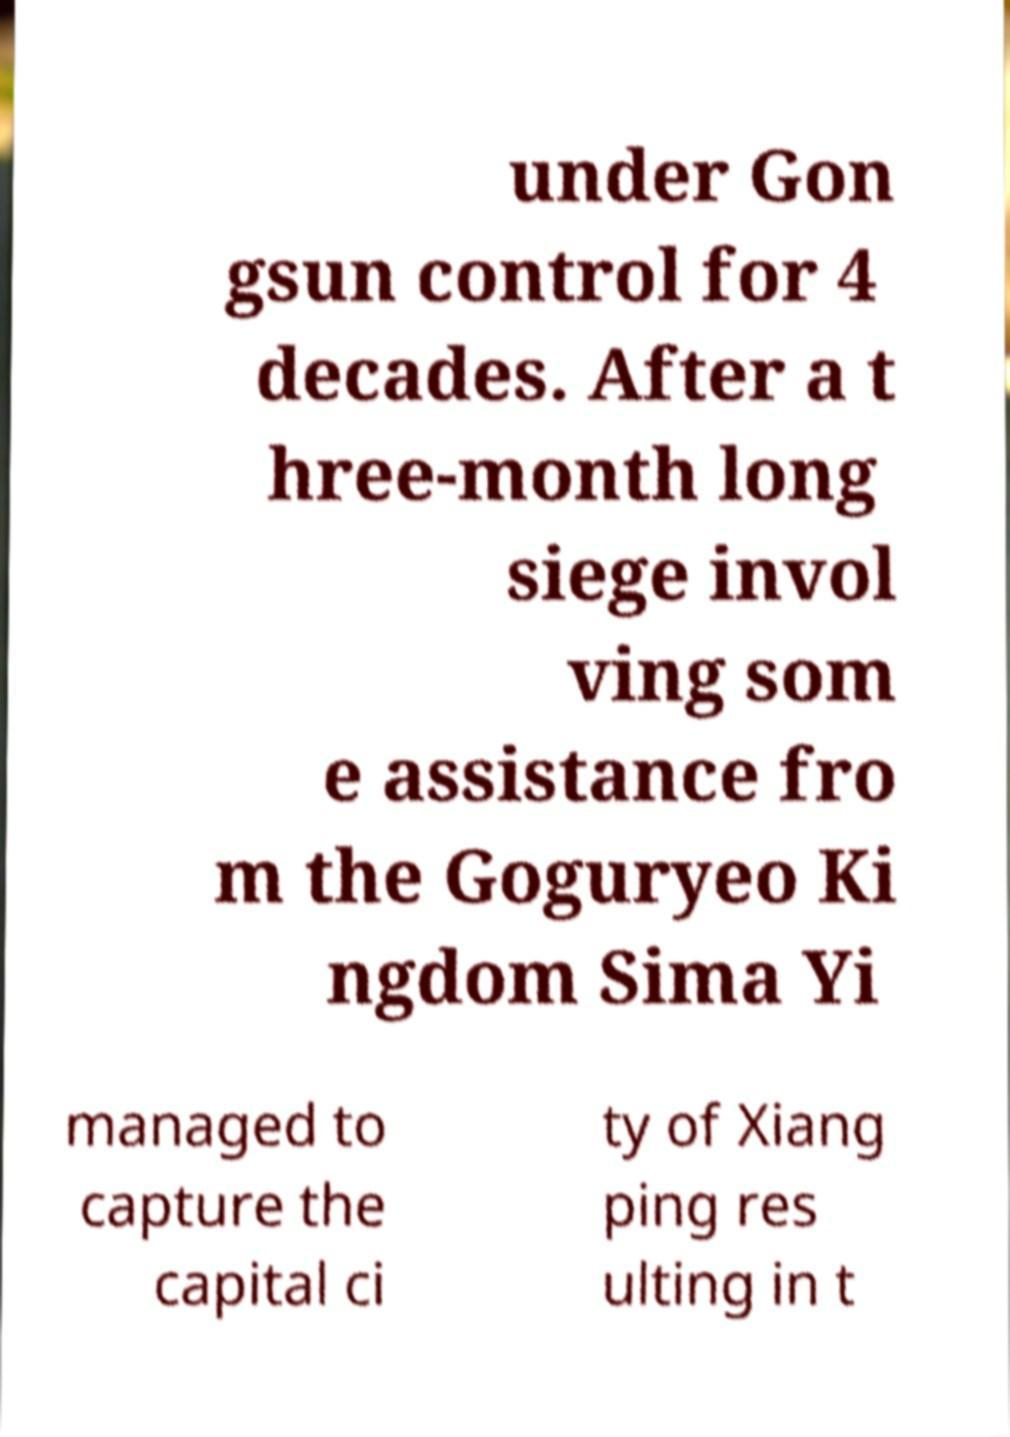Can you accurately transcribe the text from the provided image for me? under Gon gsun control for 4 decades. After a t hree-month long siege invol ving som e assistance fro m the Goguryeo Ki ngdom Sima Yi managed to capture the capital ci ty of Xiang ping res ulting in t 